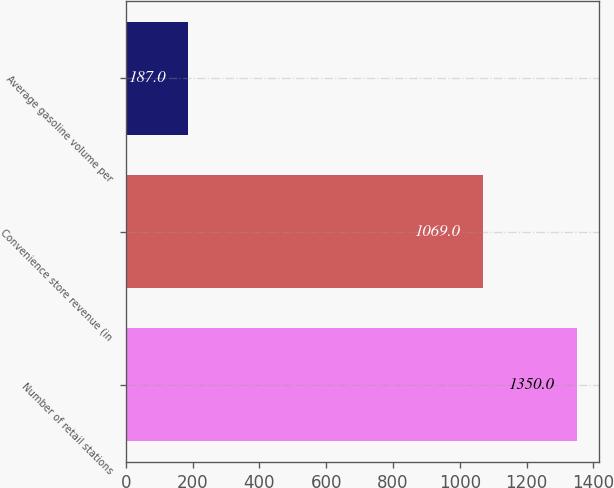<chart> <loc_0><loc_0><loc_500><loc_500><bar_chart><fcel>Number of retail stations<fcel>Convenience store revenue (in<fcel>Average gasoline volume per<nl><fcel>1350<fcel>1069<fcel>187<nl></chart> 